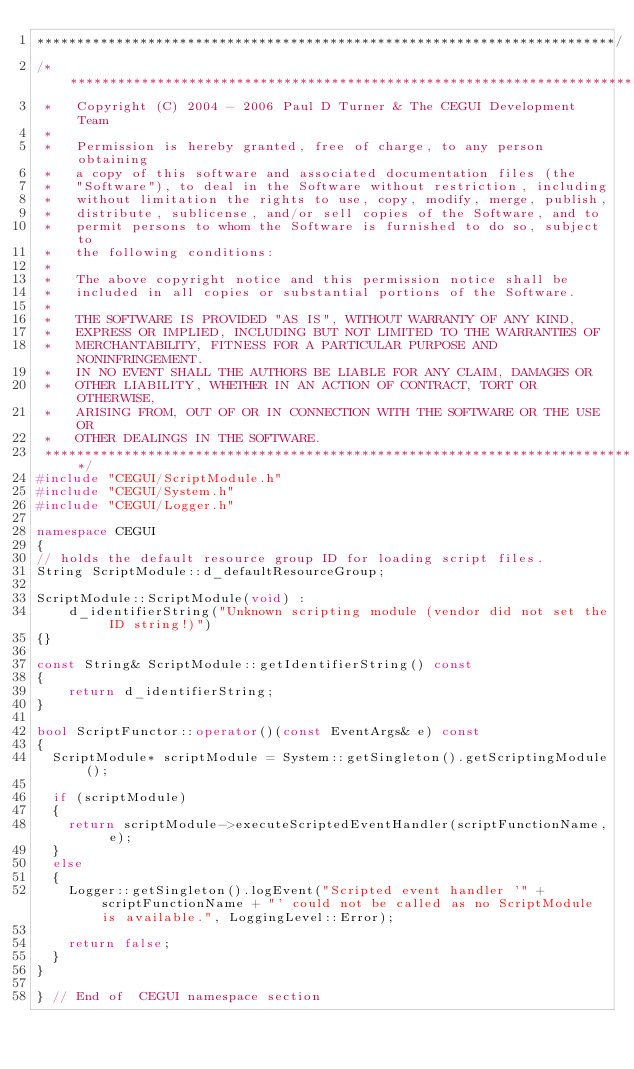<code> <loc_0><loc_0><loc_500><loc_500><_C++_>*************************************************************************/
/***************************************************************************
 *   Copyright (C) 2004 - 2006 Paul D Turner & The CEGUI Development Team
 *
 *   Permission is hereby granted, free of charge, to any person obtaining
 *   a copy of this software and associated documentation files (the
 *   "Software"), to deal in the Software without restriction, including
 *   without limitation the rights to use, copy, modify, merge, publish,
 *   distribute, sublicense, and/or sell copies of the Software, and to
 *   permit persons to whom the Software is furnished to do so, subject to
 *   the following conditions:
 *
 *   The above copyright notice and this permission notice shall be
 *   included in all copies or substantial portions of the Software.
 *
 *   THE SOFTWARE IS PROVIDED "AS IS", WITHOUT WARRANTY OF ANY KIND,
 *   EXPRESS OR IMPLIED, INCLUDING BUT NOT LIMITED TO THE WARRANTIES OF
 *   MERCHANTABILITY, FITNESS FOR A PARTICULAR PURPOSE AND NONINFRINGEMENT.
 *   IN NO EVENT SHALL THE AUTHORS BE LIABLE FOR ANY CLAIM, DAMAGES OR
 *   OTHER LIABILITY, WHETHER IN AN ACTION OF CONTRACT, TORT OR OTHERWISE,
 *   ARISING FROM, OUT OF OR IN CONNECTION WITH THE SOFTWARE OR THE USE OR
 *   OTHER DEALINGS IN THE SOFTWARE.
 ***************************************************************************/
#include "CEGUI/ScriptModule.h"
#include "CEGUI/System.h"
#include "CEGUI/Logger.h"

namespace CEGUI
{
// holds the default resource group ID for loading script files.
String ScriptModule::d_defaultResourceGroup;

ScriptModule::ScriptModule(void) :
    d_identifierString("Unknown scripting module (vendor did not set the ID string!)")
{}

const String& ScriptModule::getIdentifierString() const
{
    return d_identifierString;
}

bool ScriptFunctor::operator()(const EventArgs& e) const
{
	ScriptModule* scriptModule = System::getSingleton().getScriptingModule();

	if (scriptModule)
	{
		return scriptModule->executeScriptedEventHandler(scriptFunctionName, e);
	}
	else
	{
		Logger::getSingleton().logEvent("Scripted event handler '" + scriptFunctionName + "' could not be called as no ScriptModule is available.", LoggingLevel::Error);

		return false;
	}
}

} // End of  CEGUI namespace section
</code> 